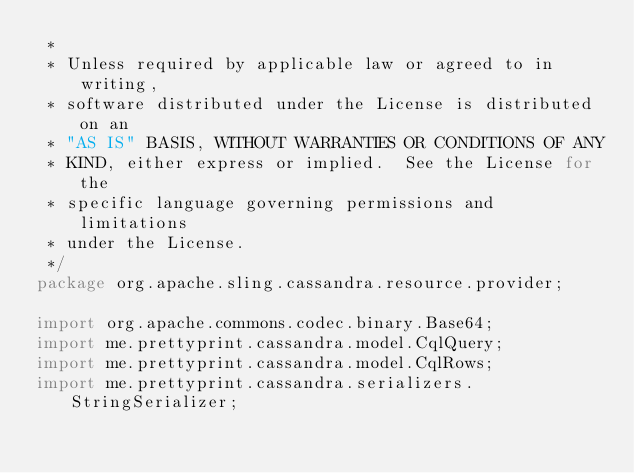<code> <loc_0><loc_0><loc_500><loc_500><_Java_> *
 * Unless required by applicable law or agreed to in writing,
 * software distributed under the License is distributed on an
 * "AS IS" BASIS, WITHOUT WARRANTIES OR CONDITIONS OF ANY
 * KIND, either express or implied.  See the License for the
 * specific language governing permissions and limitations
 * under the License.
 */
package org.apache.sling.cassandra.resource.provider;

import org.apache.commons.codec.binary.Base64;
import me.prettyprint.cassandra.model.CqlQuery;
import me.prettyprint.cassandra.model.CqlRows;
import me.prettyprint.cassandra.serializers.StringSerializer;</code> 